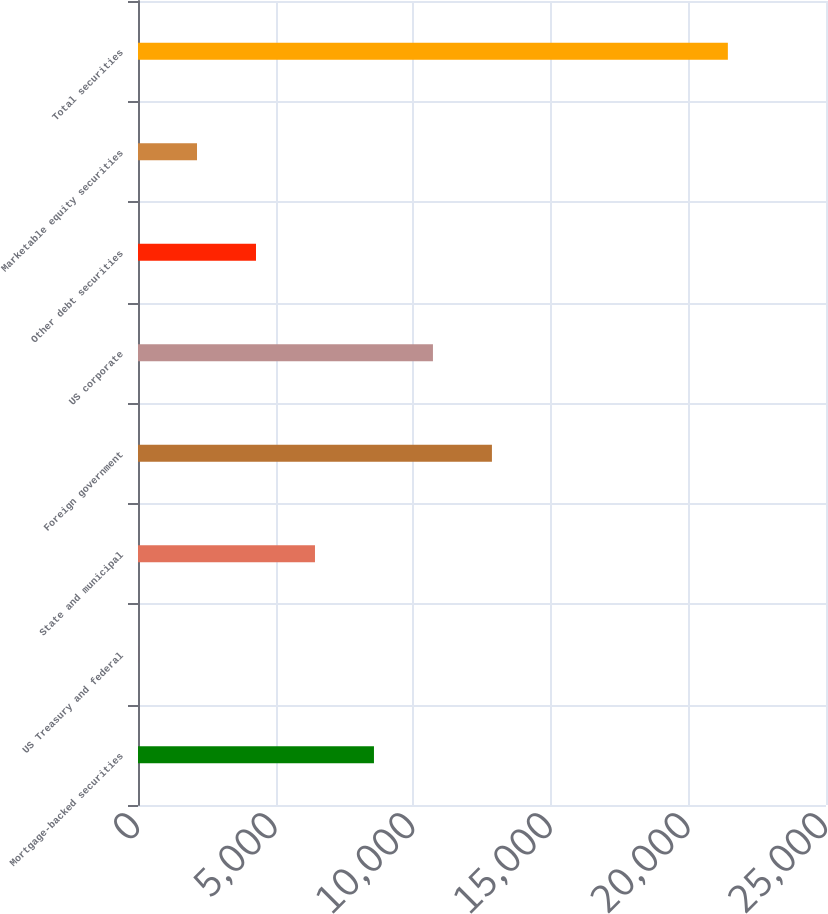<chart> <loc_0><loc_0><loc_500><loc_500><bar_chart><fcel>Mortgage-backed securities<fcel>US Treasury and federal<fcel>State and municipal<fcel>Foreign government<fcel>US corporate<fcel>Other debt securities<fcel>Marketable equity securities<fcel>Total securities<nl><fcel>8574.2<fcel>1<fcel>6430.9<fcel>12860.8<fcel>10717.5<fcel>4287.6<fcel>2144.3<fcel>21434<nl></chart> 